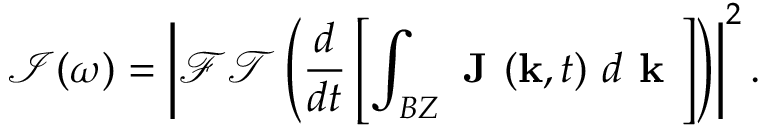Convert formula to latex. <formula><loc_0><loc_0><loc_500><loc_500>\mathcal { I } ( \omega ) = \left | \mathcal { F T } \left ( \frac { d } { d t } \left [ \int _ { B Z } J ( k , t ) d { k } \right ] \right ) \right | ^ { 2 } .</formula> 